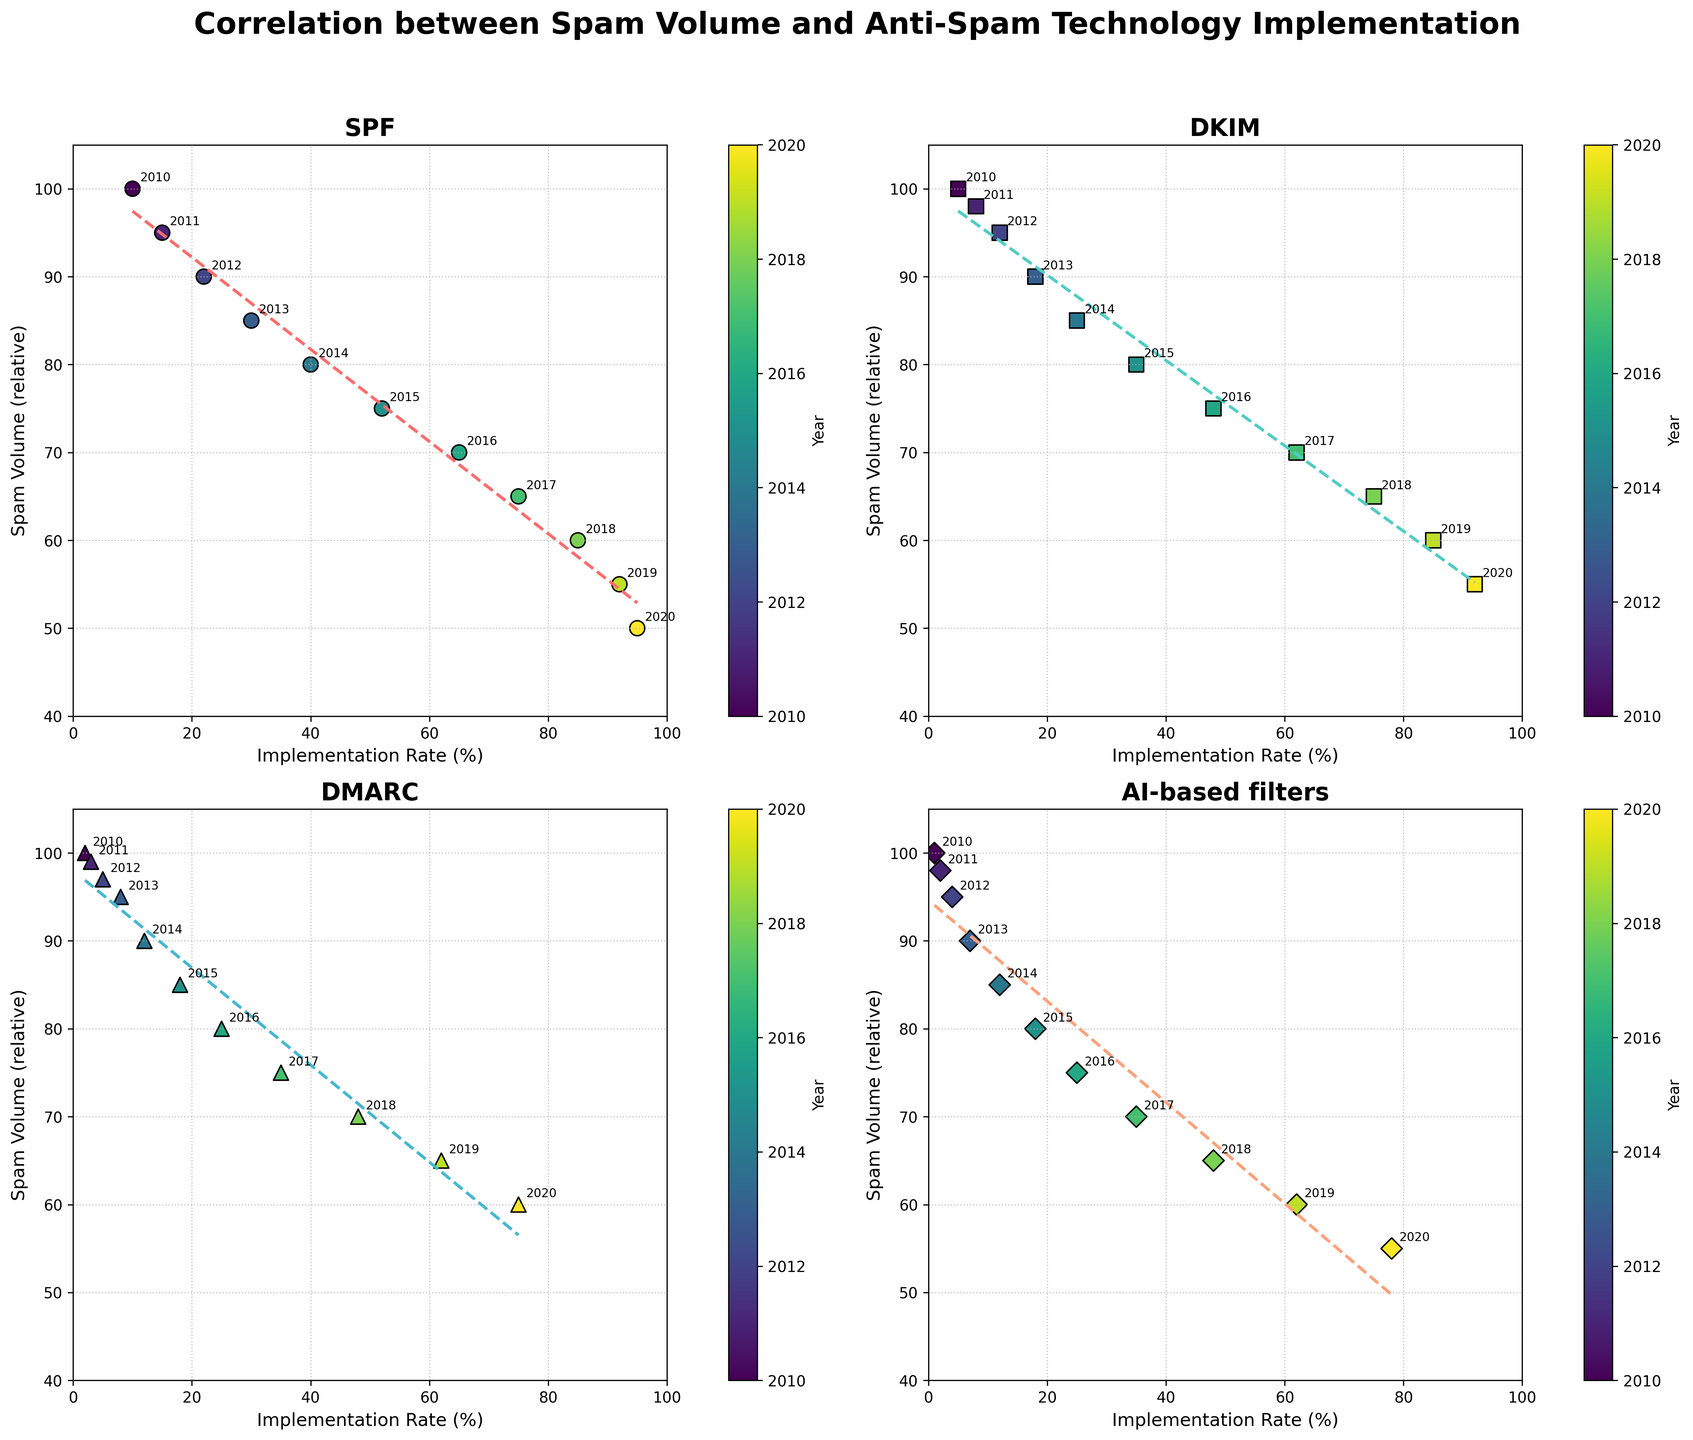What is the trend in spam volume as the implementation rate of SPF technology increases over the years? As the implementation rate of SPF increases from 10% to 95%, the spam volume decreases consistently from 100 to 50. This trend indicates an inverse relationship between SPF implementation rate and spam volume over the years.
Answer: Spam volume decreases as SPF implementation rate increases Which anti-spam technology shows the fastest decline in spam volume with increasing implementation rate? By comparing the slopes of the trend lines for each technology, DMARC shows the fastest decline in spam volume as its implementation rate increases. The line for DMARC has a steeper negative slope compared to SPF, DKIM, and AI-based filters.
Answer: DMARC At an implementation rate of around 50%, which technology shows the lowest spam volume? Checking the plot, at an implementation rate of around 50%, SPF shows a spam volume of about 75, DKIM around 80, DMARC around 85, and AI-based filters also around 85. Thus, SPF shows the lowest spam volume.
Answer: SPF What is the correlation between implementation rate and spam volume for AI-based filters? The scatter plot for AI-based filters shows that as the implementation rate increases, the spam volume consistently decreases. This strong negative correlation is shown by the downward trend in the data points and the fitted dashed line.
Answer: Strong negative correlation How did the spam volume change for DKIM from 2010 to 2020, and how does it compare to the change in implementation rate over the same period? For DKIM, the spam volume decreased from 100 in 2010 to 55 in 2020, indicating a reduction of 45 units. At the same time, the implementation rate increased from 5% to 92%, indicating an increase of 87 percentage points. This shows that as DKIM implementation rate increased significantly, the spam volume decreased notably but at a lower reduction rate.
Answer: Spam volume decreased by 45 units, while implementation rate increased by 87 percentage points Analyzing the color gradient, which technology started with the lowest implementation rate in 2010 and how does it compare with the implementation rate in 2020? AI-based filters started with the lowest implementation rate in 2010 at 1% and increased to 78% in 2020. Compared to other technologies, it had the lowest start but still shows a significant increase by 2020.
Answer: AI-based filters started at 1% in 2010 and increased to 78% in 2020 Between 2018 and 2020, which technology had the smallest change in spam volume? By directly inspecting the plot, DMARC shows a reduction in spam volume from 70 in 2018 to 60 in 2020, a difference of 10 units. SPF and DKIM show similar differences, but AI-based filters show an 8-unit reduction, indicating the smallest change among the technologies.
Answer: AI-based filters Comparing all the technology plots, which one had the most consistent reduction in spam volume over the years? By examining the trend lines for each technology, SPF shows the most consistent reduction in spam volume over the years. The line for SPF demonstrates a steady decrease without significant fluctuations.
Answer: SPF Which year had the highest spam volume for all four technologies? According to the color gradient identifying the year, 2010 is marked by the darkest shade in each subplot and shows the highest spam volume for SPF, DKIM, DMARC, and AI-based filters.
Answer: 2010 